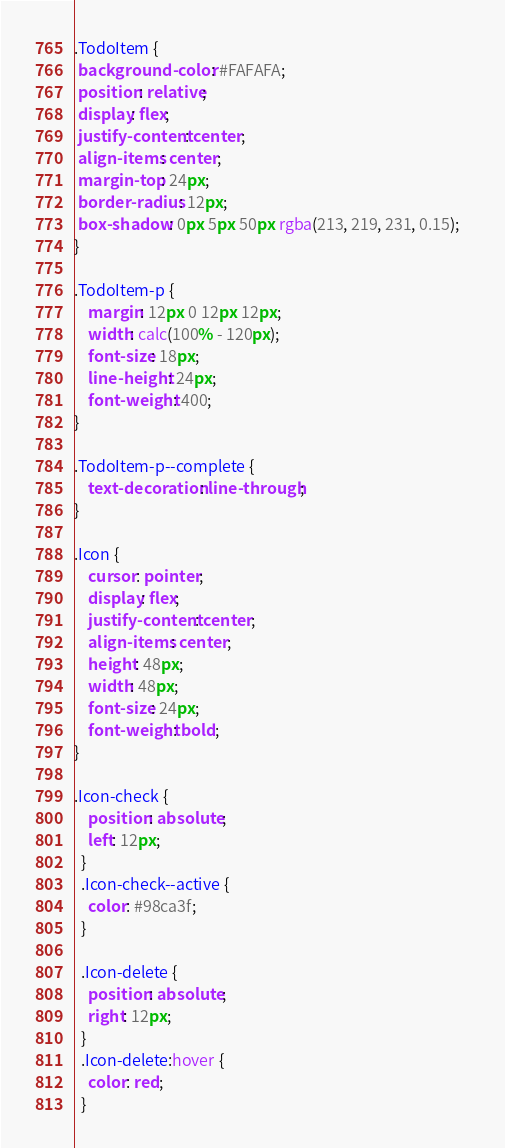Convert code to text. <code><loc_0><loc_0><loc_500><loc_500><_CSS_>.TodoItem {
 background-color: #FAFAFA;
 position: relative;
 display: flex;
 justify-content: center;
 align-items: center;
 margin-top: 24px;
 border-radius: 12px;
 box-shadow: 0px 5px 50px rgba(213, 219, 231, 0.15);   
}

.TodoItem-p {
    margin: 12px 0 12px 12px;
    width: calc(100% - 120px);
    font-size: 18px;
    line-height: 24px;
    font-weight: 400;
}

.TodoItem-p--complete {
    text-decoration: line-through;
}

.Icon {
    cursor: pointer;
    display: flex;
    justify-content: center;
    align-items: center;
    height: 48px;
    width: 48px;
    font-size: 24px;
    font-weight: bold;
}

.Icon-check {
    position: absolute;
    left: 12px;
  }
  .Icon-check--active {
    color: #98ca3f;
  }
  
  .Icon-delete {
    position: absolute;
    right: 12px;
  }
  .Icon-delete:hover {
    color: red;
  }</code> 